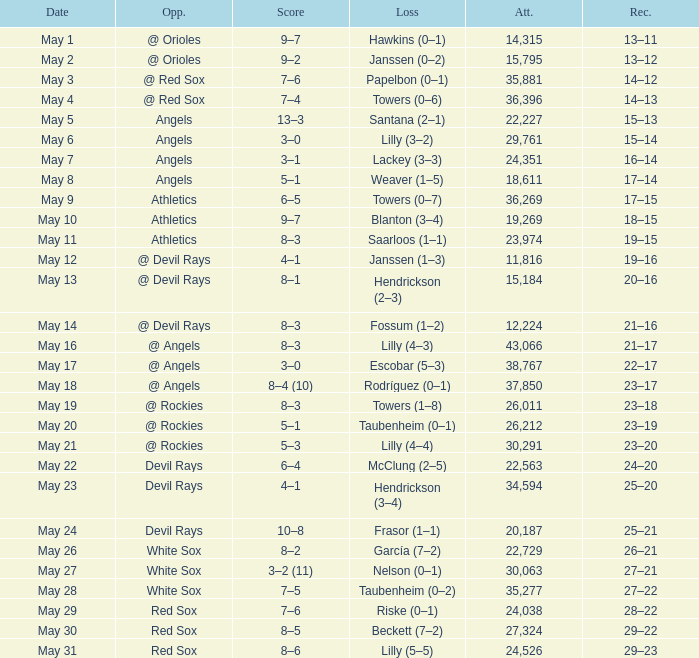When the team had their record of 16–14, what was the total attendance? 1.0. 